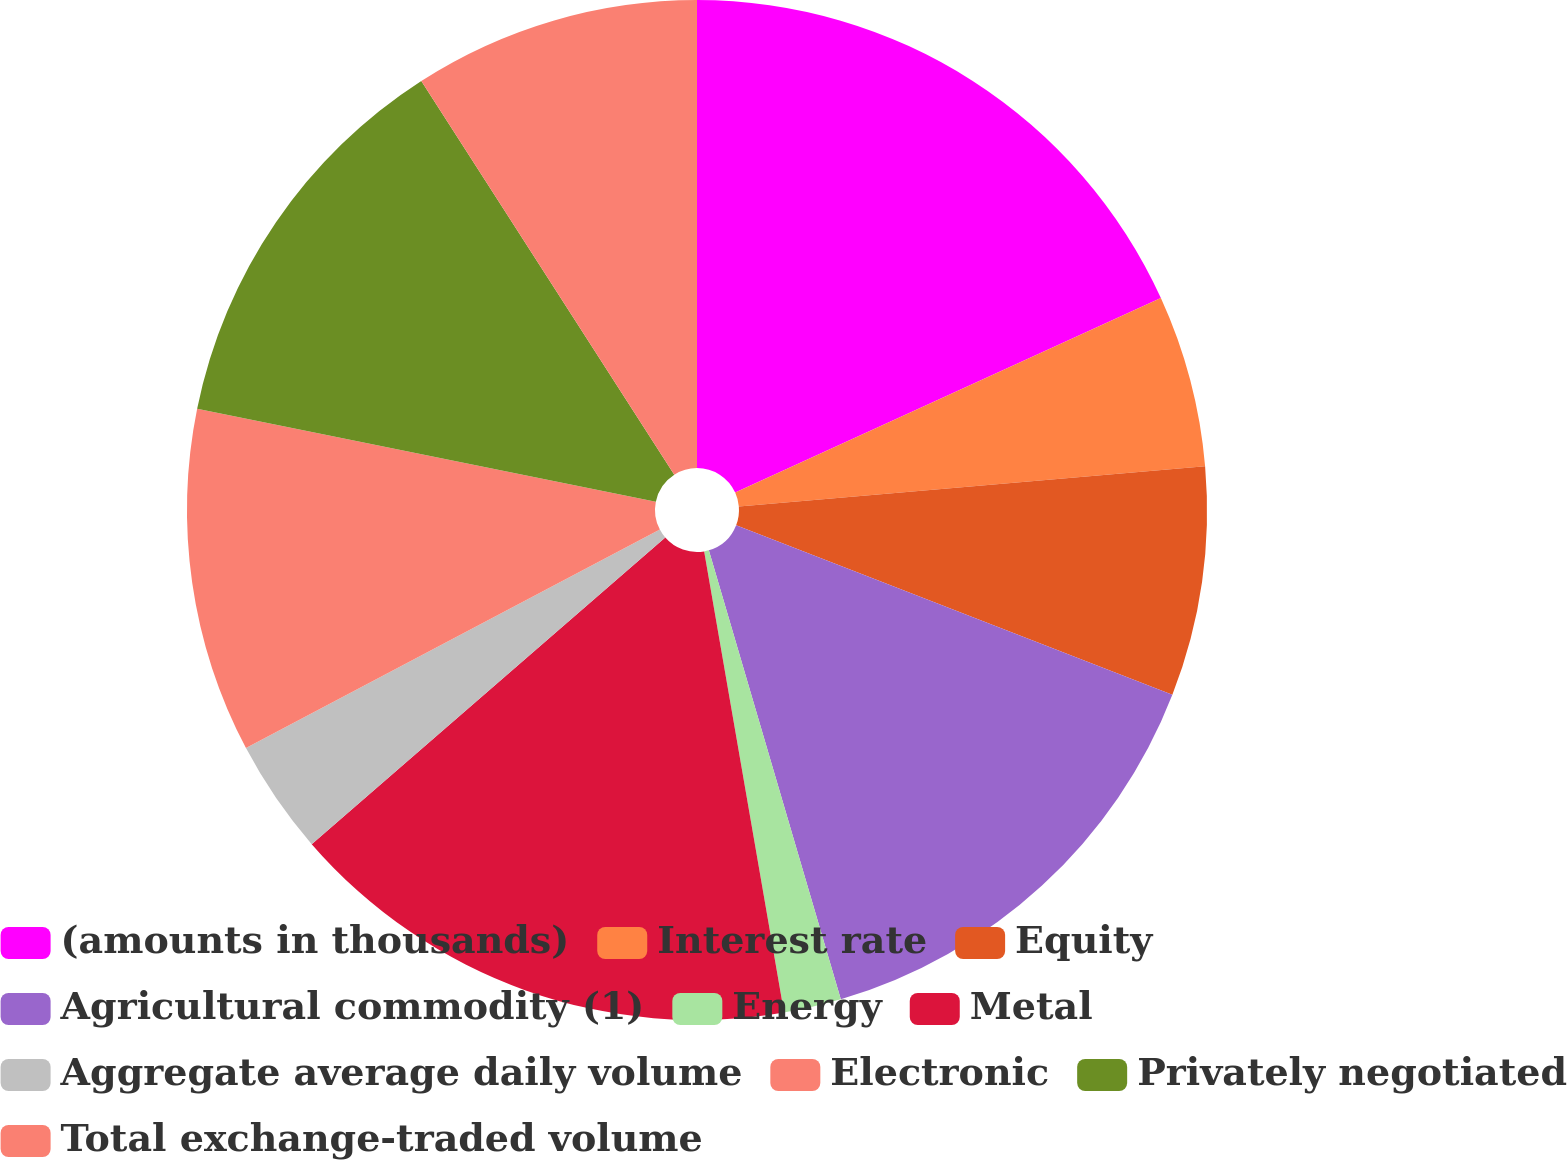Convert chart. <chart><loc_0><loc_0><loc_500><loc_500><pie_chart><fcel>(amounts in thousands)<fcel>Interest rate<fcel>Equity<fcel>Agricultural commodity (1)<fcel>Energy<fcel>Metal<fcel>Aggregate average daily volume<fcel>Electronic<fcel>Privately negotiated<fcel>Total exchange-traded volume<nl><fcel>18.18%<fcel>5.45%<fcel>7.27%<fcel>14.55%<fcel>1.82%<fcel>16.36%<fcel>3.64%<fcel>10.91%<fcel>12.73%<fcel>9.09%<nl></chart> 